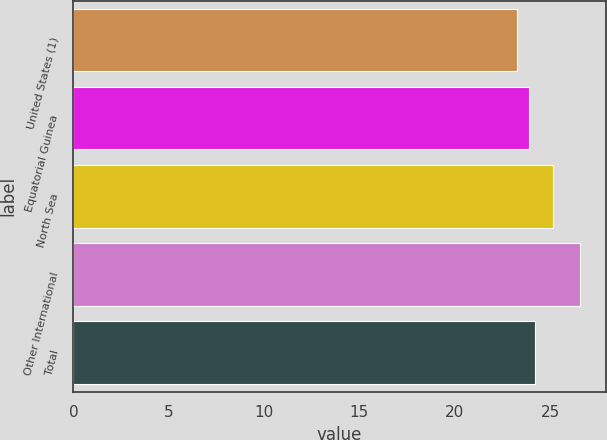Convert chart. <chart><loc_0><loc_0><loc_500><loc_500><bar_chart><fcel>United States (1)<fcel>Equatorial Guinea<fcel>North Sea<fcel>Other International<fcel>Total<nl><fcel>23.29<fcel>23.88<fcel>25.15<fcel>26.58<fcel>24.22<nl></chart> 